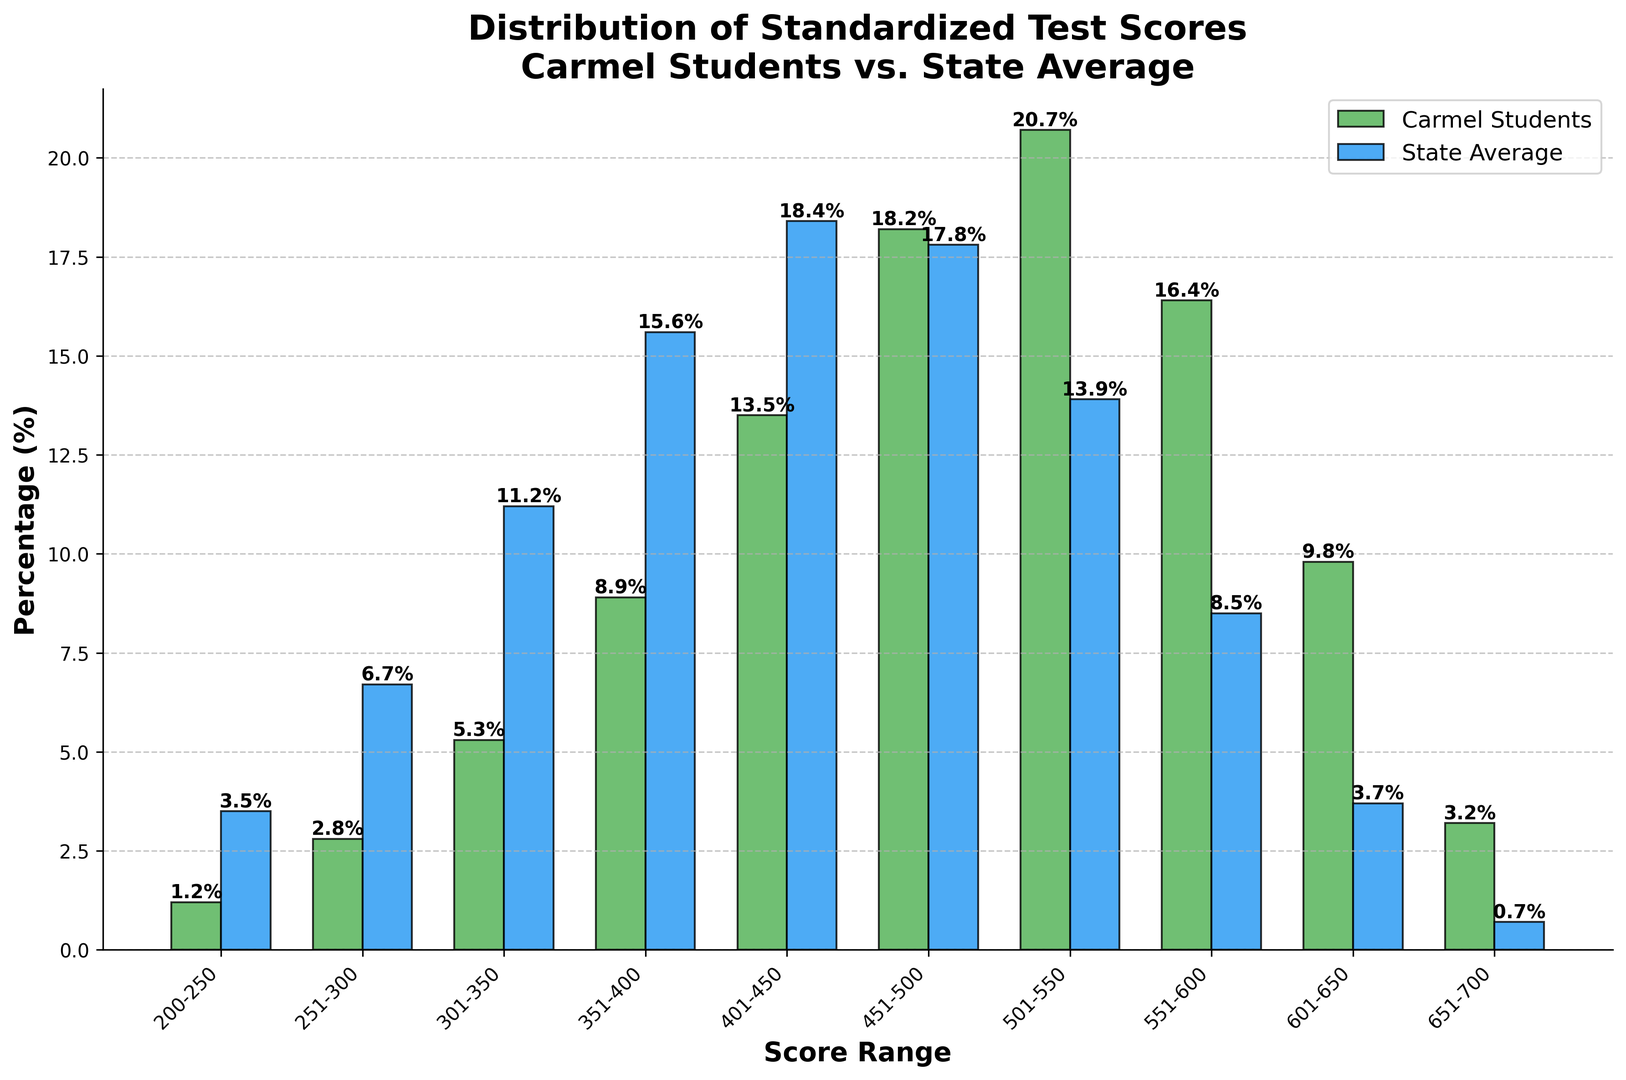What percentage of Carmel students scored between 501-550? Look at the bar representing the score range 501-550 for Carmel students. The height of the bar is labeled as 20.7%.
Answer: 20.7% Which score range has the highest percentage of state average scores? Comparing all the blue bars, the highest blue bar is in the score range 401-450, which is 18.4%.
Answer: 401-450 How much higher is the percentage of Carmel students scoring between 551-600 compared to the state average in the same range? Subtract the state average percentage (8.5%) from the Carmel students percentage (16.4%) for the range 551-600. 16.4% - 8.5% = 7.9%.
Answer: 7.9% In which score range is the difference between Carmel students and state average the greatest? Calculate the absolute difference between Carmel students and state average for each range. The greatest difference is in the range 501-550: 20.7% (Carmel) - 13.9% (State) = 6.8%.
Answer: 501-550 What is the combined percentage of Carmel students scoring between 601-650 and 651-700? Add the percentages for the ranges 601-650 (9.8%) and 651-700 (3.2%). 9.8% + 3.2% = 13%.
Answer: 13% Are there any score ranges where the state average is higher than the percentage for Carmel students? Compare the heights of the blue bars for the state average with the green bars for Carmel students in each score range. The state average is higher in the following ranges: 200-250, 251-300, 301-350, 351-400, and 401-450.
Answer: Yes What is the total percentage of Carmel students who scored above 500? Sum the percentages for the ranges 501-550, 551-600, 601-650, and 651-700: 20.7% + 16.4% + 9.8% + 3.2% = 50.1%.
Answer: 50.1% How many score ranges have a higher percentage of Carmel students compared to the state average? Count the score ranges where the green bar height is higher than the blue bar height. There are 5 ranges: 451-500, 501-550, 551-600, 601-650, and 651-700.
Answer: 5 What is the ratio of the percentage of Carmel students scoring between 451-500 to the state average in the same range? Divide the Carmel students percentage (18.2%) by the state average percentage (17.8%) for the range 451-500. 18.2% / 17.8% = 1.022, approximately 1.02.
Answer: 1.02 